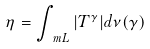Convert formula to latex. <formula><loc_0><loc_0><loc_500><loc_500>\eta = \int _ { \ m L } | T ^ { \gamma } | d \nu ( \gamma )</formula> 